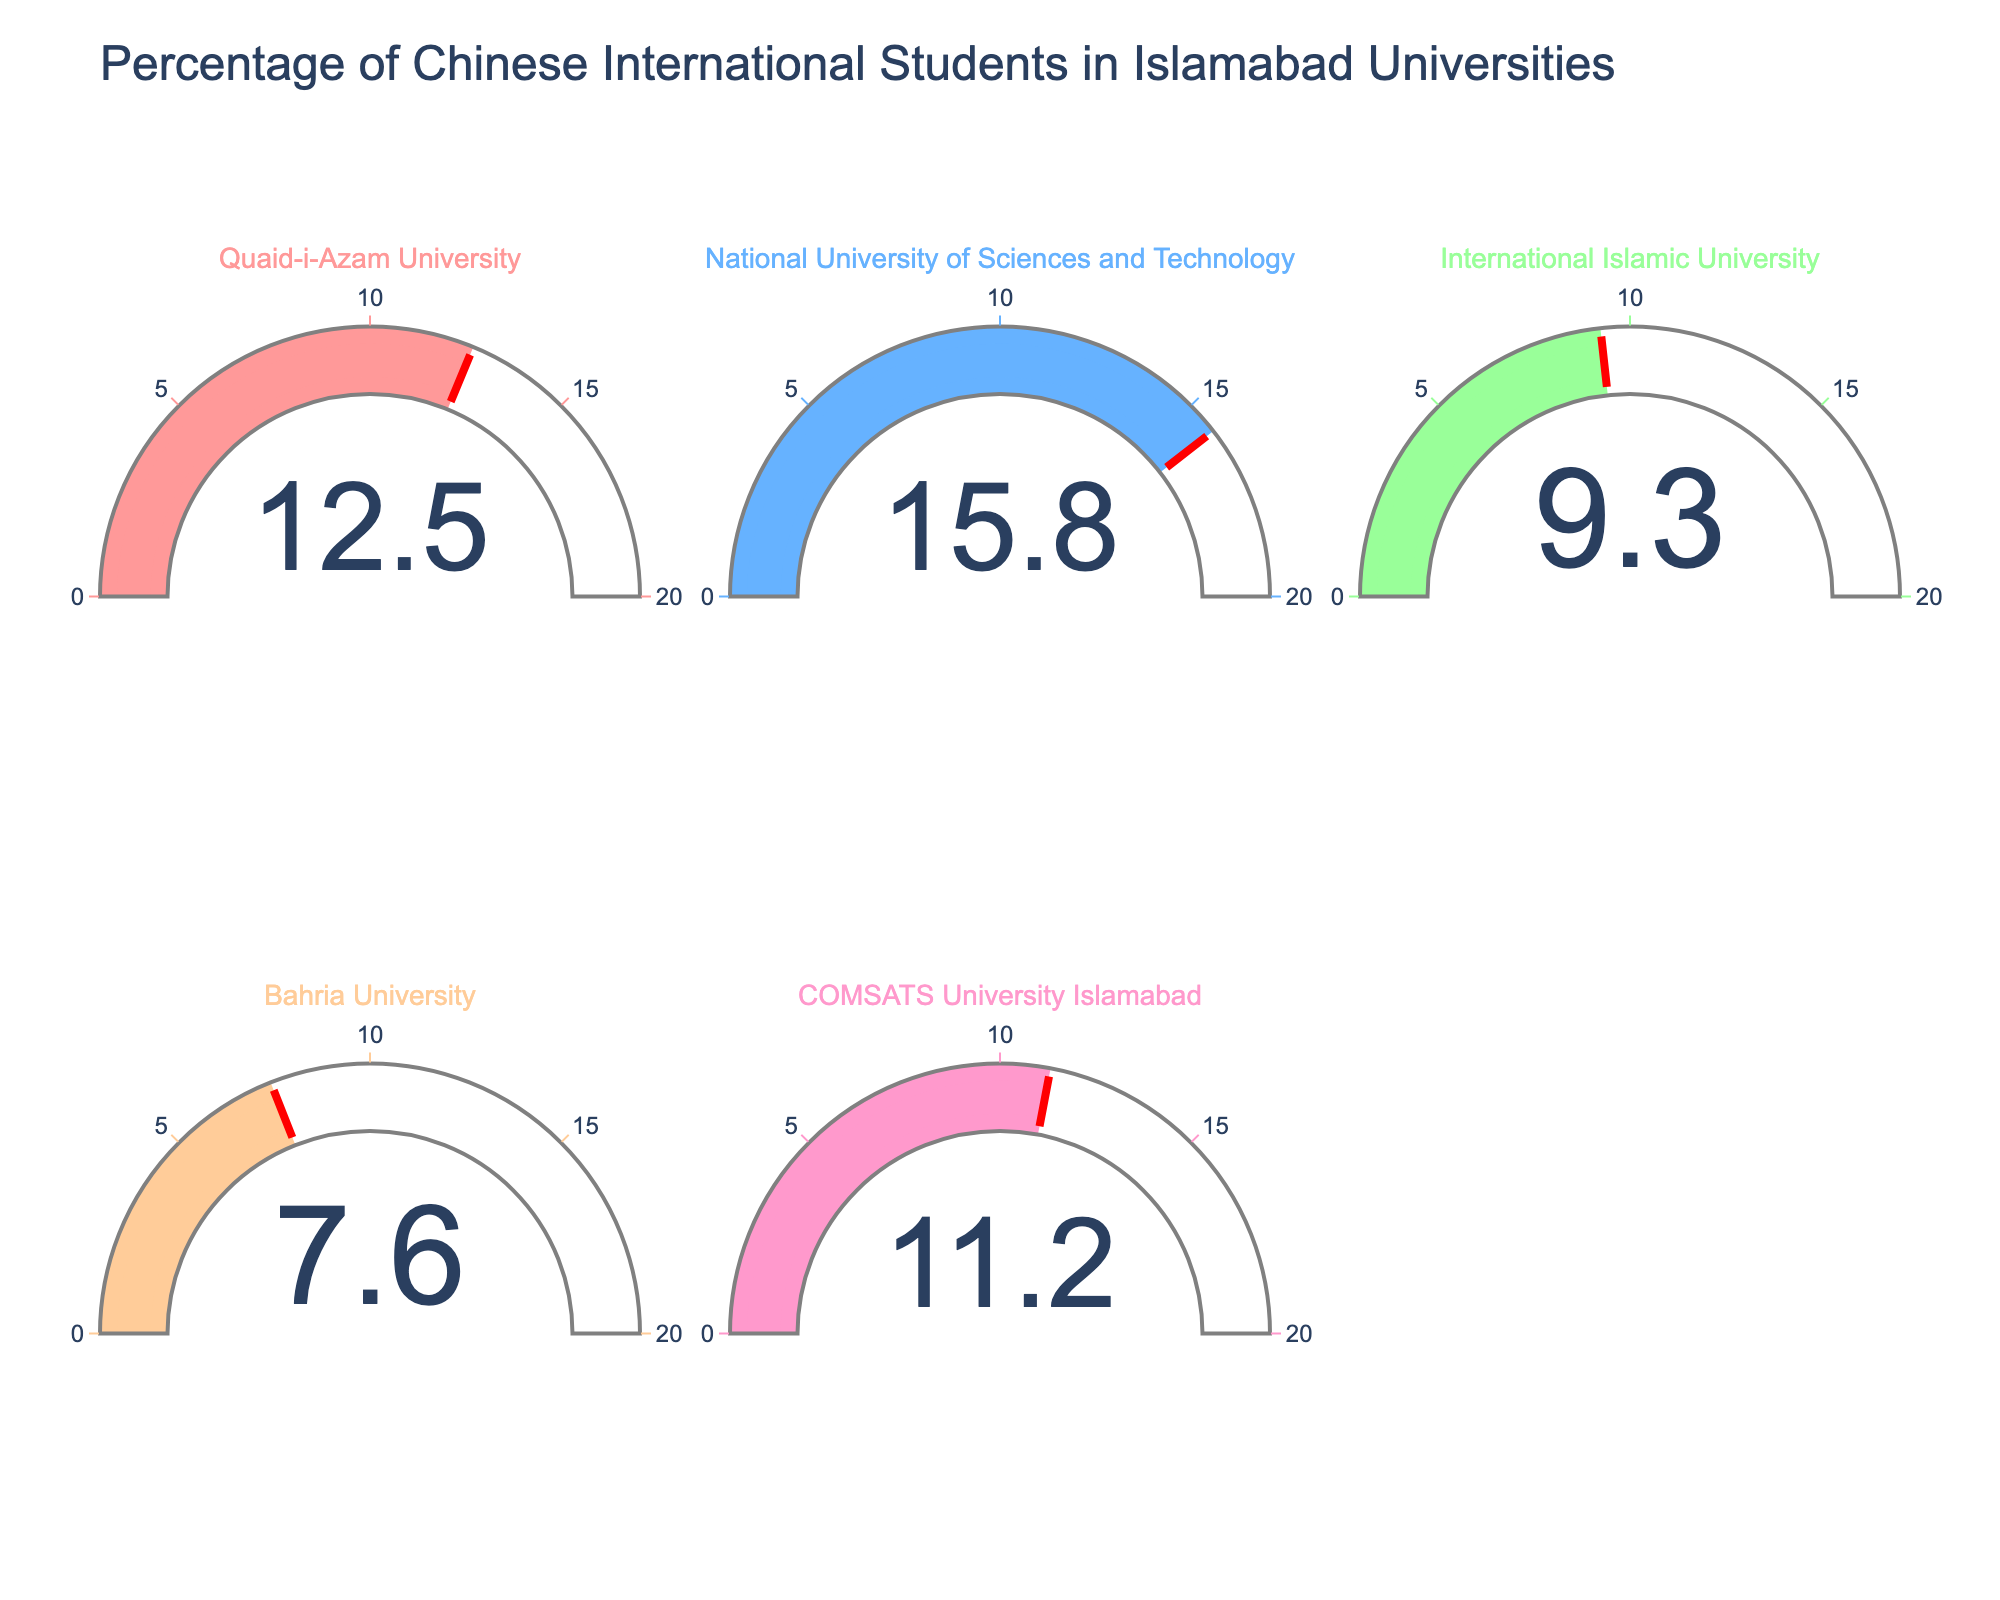How many universities are displayed in the gauge chart? The gauge chart is divided into six slots, but one is empty and the remaining five slots each display one university.
Answer: 5 What is the title of the figure? The title is displayed at the top of the figure. It reads: "Percentage of Chinese International Students in Islamabad Universities".
Answer: Percentage of Chinese International Students in Islamabad Universities Which university has the highest percentage of Chinese international students? To determine this, look at the gauge showing the highest value. The gauge for National University of Sciences and Technology shows 15.8%, which is the highest percentage.
Answer: National University of Sciences and Technology What is the approximate average percentage of Chinese international students across all listed universities? Add the percentages (12.5 + 15.8 + 9.3 + 7.6 + 11.2) to get a sum of 56.4, then divide by 5 (the number of universities). The calculation is 56.4 / 5 = 11.28%.
Answer: 11.28% Which university has the lowest percentage of Chinese international students and what is that percentage? The gauge showing the lowest value corresponds to Bahria University, which has a percentage of 7.6%.
Answer: Bahria University, 7.6% By how much does the percentage of Chinese international students at COMSATS University Islamabad exceed that at Bahria University? Subtract the percentage for Bahria University from that for COMSATS University Islamabad (11.2 - 7.6). The result is 3.6%.
Answer: 3.6% What is the range of percentages displayed on the gauges? The percentages on the gauges range from the lowest value of 7.6% (Bahria University) to the highest value of 15.8% (National University of Sciences and Technology).
Answer: 7.6% to 15.8% How many colors are used in the gauge bars, and what might be the reason for using different colors? There are five different colors used in the gauge bars. Different colors help distinguish the universities more easily and make the chart visually appealing.
Answer: 5 colors, for distinction and visual appeal What is the percentage difference between the Chinese international students at Quaid-i-Azam University and International Islamic University? Subtract the percentage for International Islamic University from that for Quaid-i-Azam University (12.5 - 9.3). The difference is 3.2%.
Answer: 3.2% What is the median percentage of Chinese international students among the listed universities? Arrange the percentages in ascending order (7.6, 9.3, 11.2, 12.5, 15.8). The median is the middle value, which is 11.2%.
Answer: 11.2% 